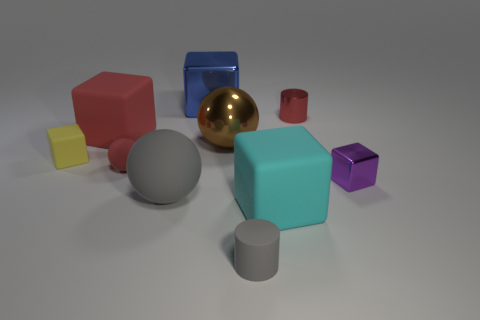Are there the same number of large blue things right of the large cyan object and blue shiny blocks?
Give a very brief answer. No. Are there any brown balls behind the red cylinder?
Offer a very short reply. No. What size is the red thing behind the large rubber object behind the block right of the cyan block?
Ensure brevity in your answer.  Small. There is a gray object that is on the right side of the gray matte sphere; is its shape the same as the red object on the right side of the gray cylinder?
Offer a very short reply. Yes. The red matte thing that is the same shape as the brown thing is what size?
Give a very brief answer. Small. What number of big brown spheres are the same material as the small red sphere?
Keep it short and to the point. 0. What is the small gray cylinder made of?
Your answer should be compact. Rubber. What shape is the tiny matte object in front of the metallic cube in front of the red cylinder?
Ensure brevity in your answer.  Cylinder. There is a small red thing that is in front of the brown metallic ball; what shape is it?
Provide a short and direct response. Sphere. How many small rubber balls are the same color as the matte cylinder?
Your answer should be compact. 0. 